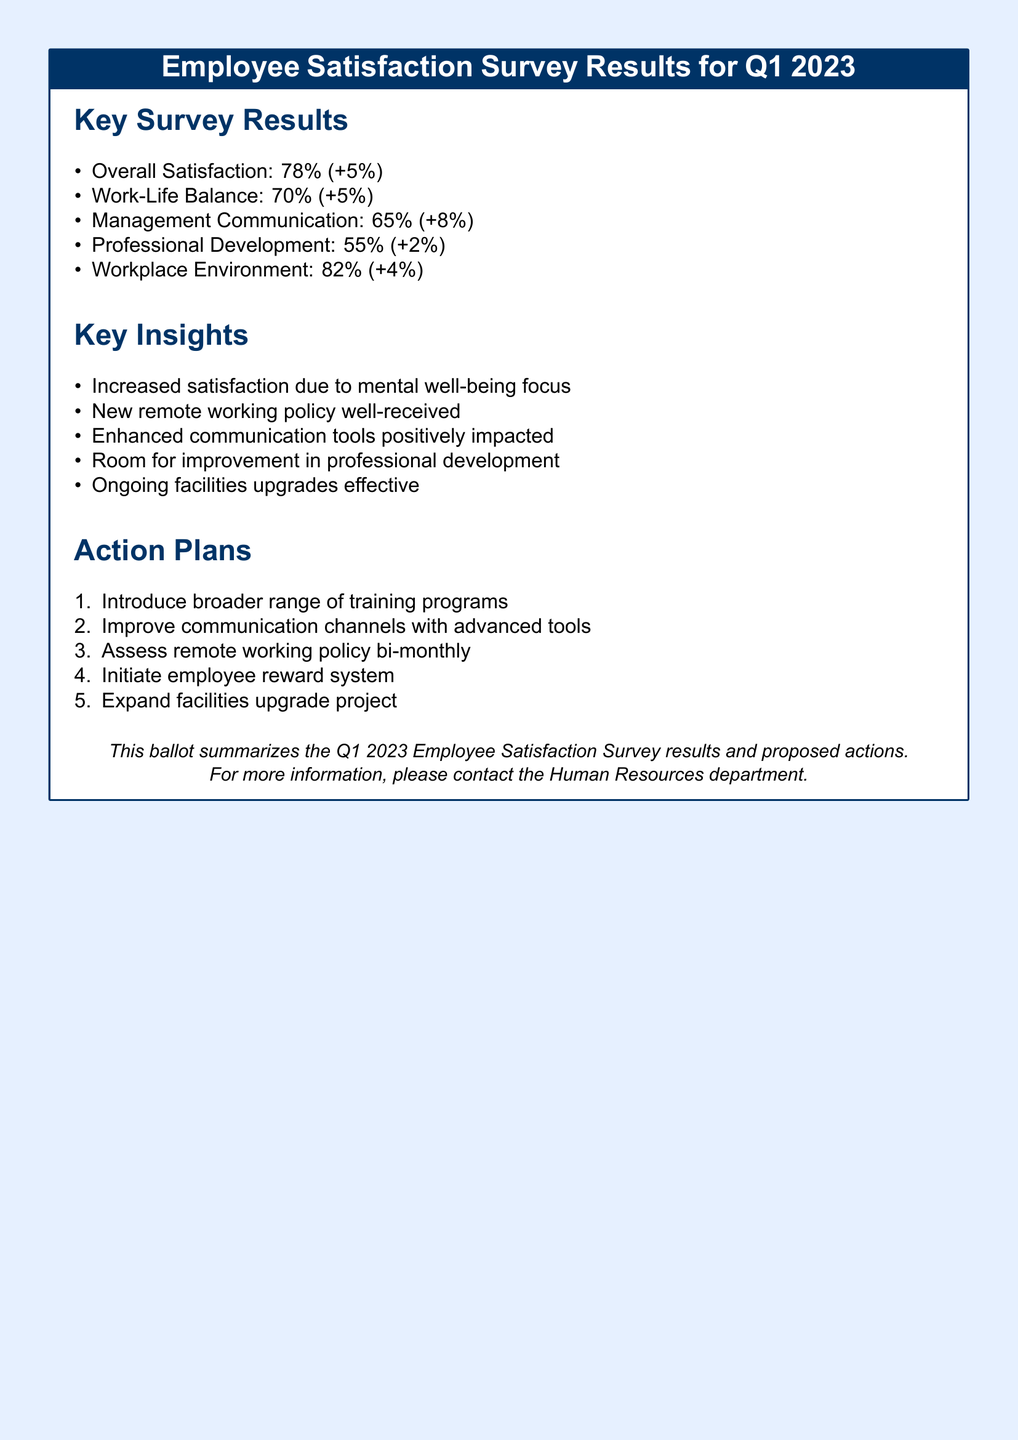What is the overall satisfaction percentage? The overall satisfaction is explicitly mentioned in the survey results section.
Answer: 78% What was the increase in management communication satisfaction? The increase in management communication satisfaction is provided in the key survey results.
Answer: 8% What percentage of employees feel satisfied with their professional development? The document provides this statistic in the key survey results section.
Answer: 55% What key insight relates to the mental well-being focus? The document mentions this insight among the key insights.
Answer: Increased satisfaction due to mental well-being focus How many action plans are proposed in the document? The total number of action plans can be counted in the action plans section.
Answer: 5 What is one of the proposed actions regarding professional development? The document includes a specific action plan related to training programs.
Answer: Introduce broader range of training programs What aspect received the highest satisfaction? The document lists satisfaction percentages for various aspects, with one having the highest percentage.
Answer: Workplace Environment What does the document suggest for assessing remote work? The action plans include a specific frequency of assessment for remote working policy.
Answer: Bi-monthly 